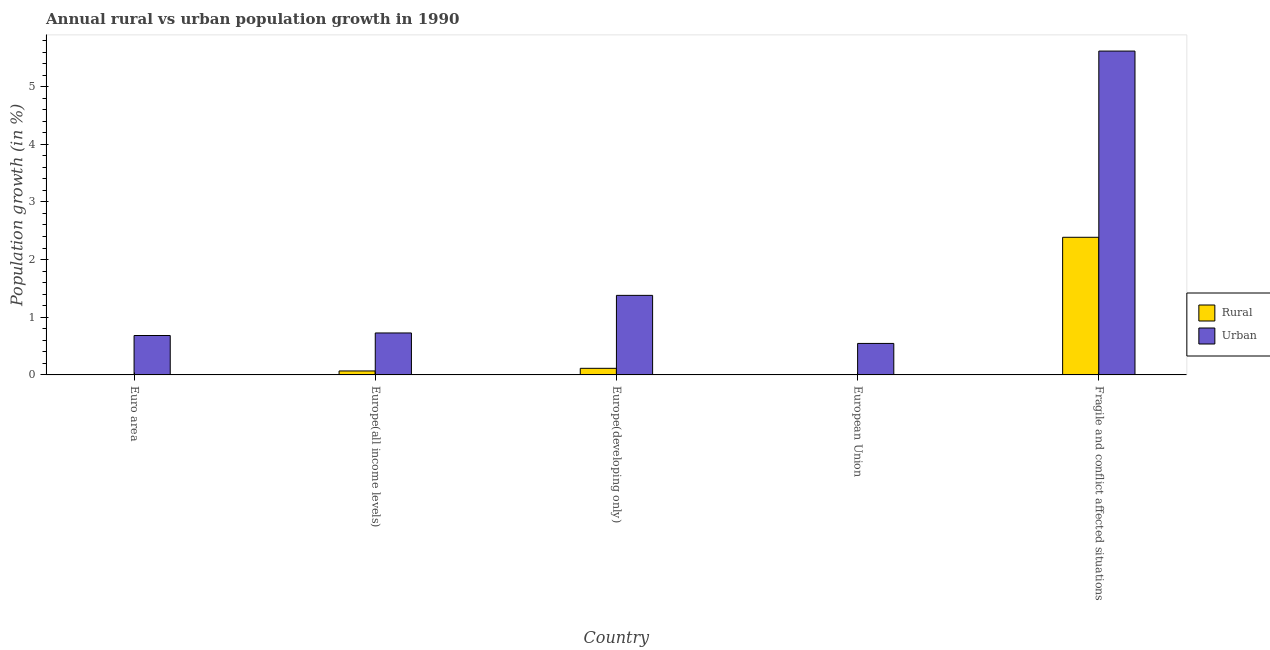How many different coloured bars are there?
Keep it short and to the point. 2. Are the number of bars per tick equal to the number of legend labels?
Offer a very short reply. No. Are the number of bars on each tick of the X-axis equal?
Your answer should be compact. No. What is the label of the 5th group of bars from the left?
Give a very brief answer. Fragile and conflict affected situations. What is the urban population growth in European Union?
Your answer should be very brief. 0.55. Across all countries, what is the maximum rural population growth?
Provide a succinct answer. 2.39. Across all countries, what is the minimum urban population growth?
Your answer should be very brief. 0.55. In which country was the urban population growth maximum?
Provide a short and direct response. Fragile and conflict affected situations. What is the total urban population growth in the graph?
Offer a very short reply. 8.95. What is the difference between the urban population growth in Euro area and that in Fragile and conflict affected situations?
Keep it short and to the point. -4.93. What is the difference between the urban population growth in Euro area and the rural population growth in Europe(all income levels)?
Make the answer very short. 0.61. What is the average rural population growth per country?
Offer a very short reply. 0.51. What is the difference between the urban population growth and rural population growth in Europe(all income levels)?
Your answer should be compact. 0.66. What is the ratio of the urban population growth in Euro area to that in Fragile and conflict affected situations?
Offer a very short reply. 0.12. Is the urban population growth in Euro area less than that in Europe(all income levels)?
Offer a very short reply. Yes. What is the difference between the highest and the second highest rural population growth?
Your answer should be compact. 2.27. What is the difference between the highest and the lowest rural population growth?
Make the answer very short. 2.39. Is the sum of the urban population growth in Euro area and Europe(developing only) greater than the maximum rural population growth across all countries?
Offer a very short reply. No. Are the values on the major ticks of Y-axis written in scientific E-notation?
Your answer should be compact. No. Does the graph contain any zero values?
Your response must be concise. Yes. How are the legend labels stacked?
Your answer should be compact. Vertical. What is the title of the graph?
Offer a terse response. Annual rural vs urban population growth in 1990. What is the label or title of the X-axis?
Give a very brief answer. Country. What is the label or title of the Y-axis?
Give a very brief answer. Population growth (in %). What is the Population growth (in %) in Urban  in Euro area?
Make the answer very short. 0.68. What is the Population growth (in %) in Rural in Europe(all income levels)?
Offer a very short reply. 0.07. What is the Population growth (in %) in Urban  in Europe(all income levels)?
Provide a short and direct response. 0.73. What is the Population growth (in %) of Rural in Europe(developing only)?
Give a very brief answer. 0.11. What is the Population growth (in %) of Urban  in Europe(developing only)?
Offer a terse response. 1.38. What is the Population growth (in %) in Rural in European Union?
Keep it short and to the point. 0. What is the Population growth (in %) in Urban  in European Union?
Make the answer very short. 0.55. What is the Population growth (in %) in Rural in Fragile and conflict affected situations?
Your answer should be compact. 2.39. What is the Population growth (in %) of Urban  in Fragile and conflict affected situations?
Provide a succinct answer. 5.62. Across all countries, what is the maximum Population growth (in %) of Rural?
Give a very brief answer. 2.39. Across all countries, what is the maximum Population growth (in %) of Urban ?
Provide a short and direct response. 5.62. Across all countries, what is the minimum Population growth (in %) in Rural?
Give a very brief answer. 0. Across all countries, what is the minimum Population growth (in %) in Urban ?
Provide a succinct answer. 0.55. What is the total Population growth (in %) of Rural in the graph?
Your answer should be compact. 2.57. What is the total Population growth (in %) of Urban  in the graph?
Provide a succinct answer. 8.95. What is the difference between the Population growth (in %) of Urban  in Euro area and that in Europe(all income levels)?
Make the answer very short. -0.04. What is the difference between the Population growth (in %) of Urban  in Euro area and that in Europe(developing only)?
Make the answer very short. -0.7. What is the difference between the Population growth (in %) in Urban  in Euro area and that in European Union?
Ensure brevity in your answer.  0.14. What is the difference between the Population growth (in %) of Urban  in Euro area and that in Fragile and conflict affected situations?
Offer a very short reply. -4.93. What is the difference between the Population growth (in %) in Rural in Europe(all income levels) and that in Europe(developing only)?
Provide a short and direct response. -0.05. What is the difference between the Population growth (in %) in Urban  in Europe(all income levels) and that in Europe(developing only)?
Your answer should be very brief. -0.65. What is the difference between the Population growth (in %) of Urban  in Europe(all income levels) and that in European Union?
Offer a terse response. 0.18. What is the difference between the Population growth (in %) of Rural in Europe(all income levels) and that in Fragile and conflict affected situations?
Offer a terse response. -2.32. What is the difference between the Population growth (in %) of Urban  in Europe(all income levels) and that in Fragile and conflict affected situations?
Ensure brevity in your answer.  -4.89. What is the difference between the Population growth (in %) of Urban  in Europe(developing only) and that in European Union?
Ensure brevity in your answer.  0.83. What is the difference between the Population growth (in %) of Rural in Europe(developing only) and that in Fragile and conflict affected situations?
Your response must be concise. -2.27. What is the difference between the Population growth (in %) in Urban  in Europe(developing only) and that in Fragile and conflict affected situations?
Your answer should be very brief. -4.24. What is the difference between the Population growth (in %) of Urban  in European Union and that in Fragile and conflict affected situations?
Your response must be concise. -5.07. What is the difference between the Population growth (in %) of Rural in Europe(all income levels) and the Population growth (in %) of Urban  in Europe(developing only)?
Offer a terse response. -1.31. What is the difference between the Population growth (in %) of Rural in Europe(all income levels) and the Population growth (in %) of Urban  in European Union?
Provide a short and direct response. -0.48. What is the difference between the Population growth (in %) of Rural in Europe(all income levels) and the Population growth (in %) of Urban  in Fragile and conflict affected situations?
Your answer should be very brief. -5.55. What is the difference between the Population growth (in %) in Rural in Europe(developing only) and the Population growth (in %) in Urban  in European Union?
Your response must be concise. -0.43. What is the difference between the Population growth (in %) in Rural in Europe(developing only) and the Population growth (in %) in Urban  in Fragile and conflict affected situations?
Keep it short and to the point. -5.5. What is the average Population growth (in %) of Rural per country?
Offer a terse response. 0.51. What is the average Population growth (in %) in Urban  per country?
Your response must be concise. 1.79. What is the difference between the Population growth (in %) of Rural and Population growth (in %) of Urban  in Europe(all income levels)?
Give a very brief answer. -0.66. What is the difference between the Population growth (in %) of Rural and Population growth (in %) of Urban  in Europe(developing only)?
Provide a succinct answer. -1.27. What is the difference between the Population growth (in %) of Rural and Population growth (in %) of Urban  in Fragile and conflict affected situations?
Your response must be concise. -3.23. What is the ratio of the Population growth (in %) of Urban  in Euro area to that in Europe(all income levels)?
Make the answer very short. 0.94. What is the ratio of the Population growth (in %) of Urban  in Euro area to that in Europe(developing only)?
Provide a short and direct response. 0.5. What is the ratio of the Population growth (in %) in Urban  in Euro area to that in European Union?
Keep it short and to the point. 1.25. What is the ratio of the Population growth (in %) of Urban  in Euro area to that in Fragile and conflict affected situations?
Ensure brevity in your answer.  0.12. What is the ratio of the Population growth (in %) of Rural in Europe(all income levels) to that in Europe(developing only)?
Your answer should be very brief. 0.6. What is the ratio of the Population growth (in %) in Urban  in Europe(all income levels) to that in Europe(developing only)?
Provide a succinct answer. 0.53. What is the ratio of the Population growth (in %) in Urban  in Europe(all income levels) to that in European Union?
Offer a terse response. 1.33. What is the ratio of the Population growth (in %) in Rural in Europe(all income levels) to that in Fragile and conflict affected situations?
Keep it short and to the point. 0.03. What is the ratio of the Population growth (in %) in Urban  in Europe(all income levels) to that in Fragile and conflict affected situations?
Offer a terse response. 0.13. What is the ratio of the Population growth (in %) of Urban  in Europe(developing only) to that in European Union?
Provide a short and direct response. 2.53. What is the ratio of the Population growth (in %) in Rural in Europe(developing only) to that in Fragile and conflict affected situations?
Give a very brief answer. 0.05. What is the ratio of the Population growth (in %) in Urban  in Europe(developing only) to that in Fragile and conflict affected situations?
Provide a succinct answer. 0.25. What is the ratio of the Population growth (in %) of Urban  in European Union to that in Fragile and conflict affected situations?
Your answer should be compact. 0.1. What is the difference between the highest and the second highest Population growth (in %) in Rural?
Offer a terse response. 2.27. What is the difference between the highest and the second highest Population growth (in %) of Urban ?
Your answer should be compact. 4.24. What is the difference between the highest and the lowest Population growth (in %) of Rural?
Offer a very short reply. 2.39. What is the difference between the highest and the lowest Population growth (in %) of Urban ?
Make the answer very short. 5.07. 